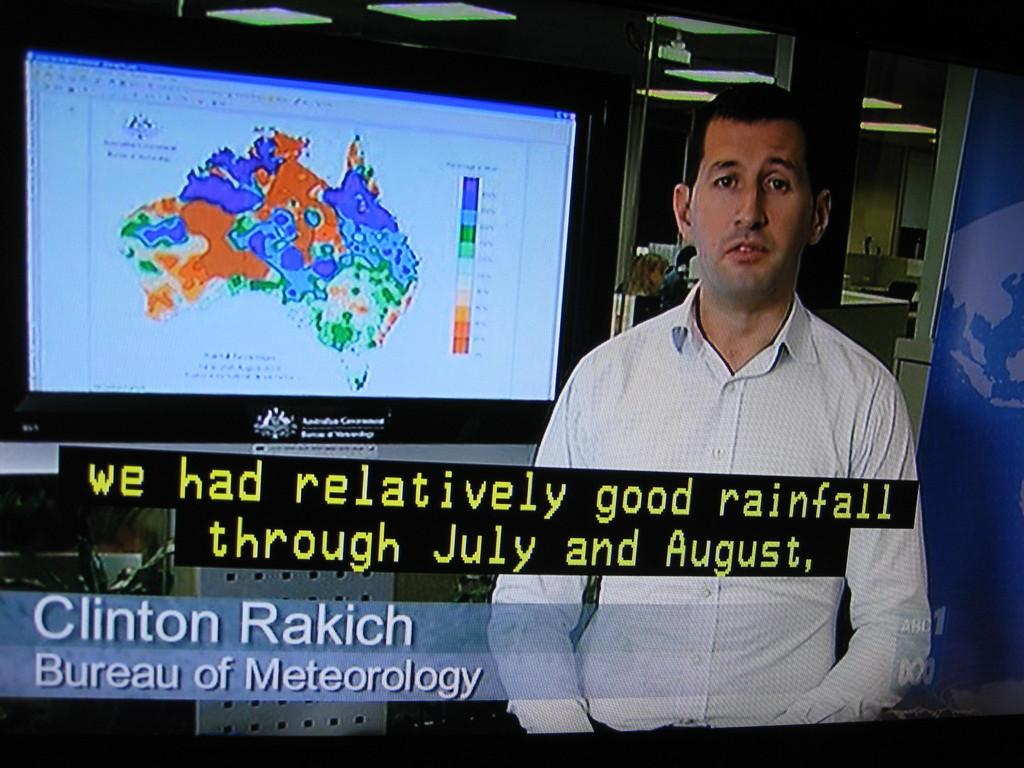What is the main subject of the image? There is a man standing in the image. What can be seen in the background of the image? There is a television screen in the background of the image. Are there any words or letters visible in the image? Yes, there is some text visible in the image. What type of shock can be seen coming from the man's pocket in the image? There is no shock or pocket visible in the image; it only features a man standing and a television screen in the background. 